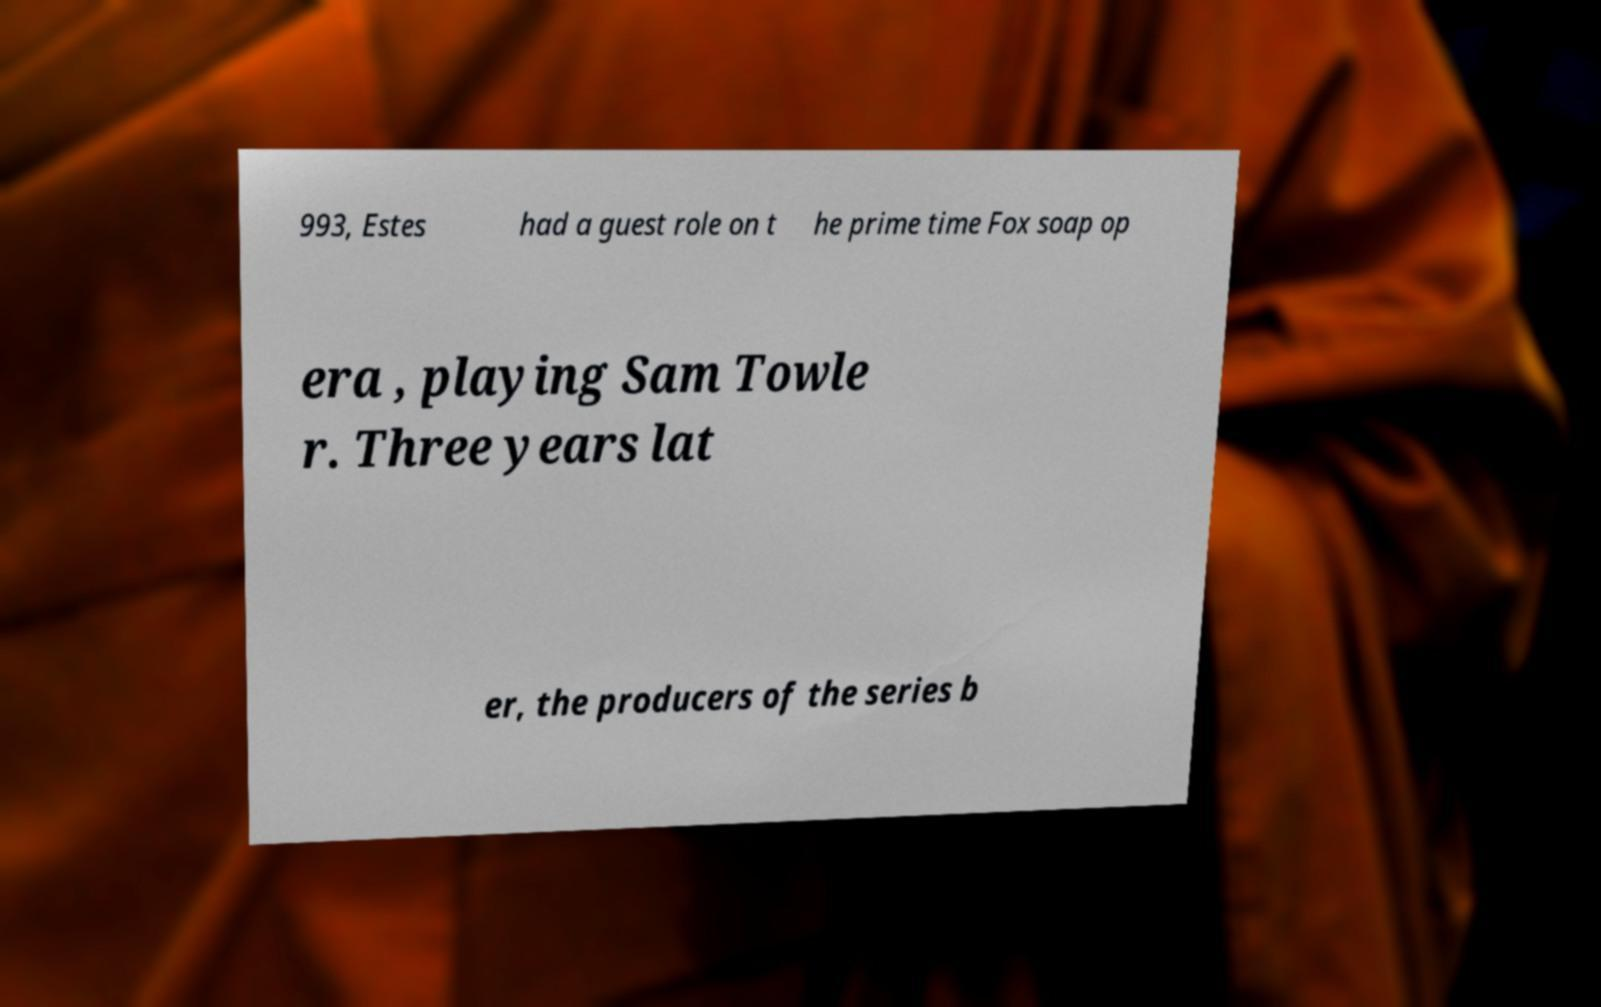Can you read and provide the text displayed in the image?This photo seems to have some interesting text. Can you extract and type it out for me? 993, Estes had a guest role on t he prime time Fox soap op era , playing Sam Towle r. Three years lat er, the producers of the series b 